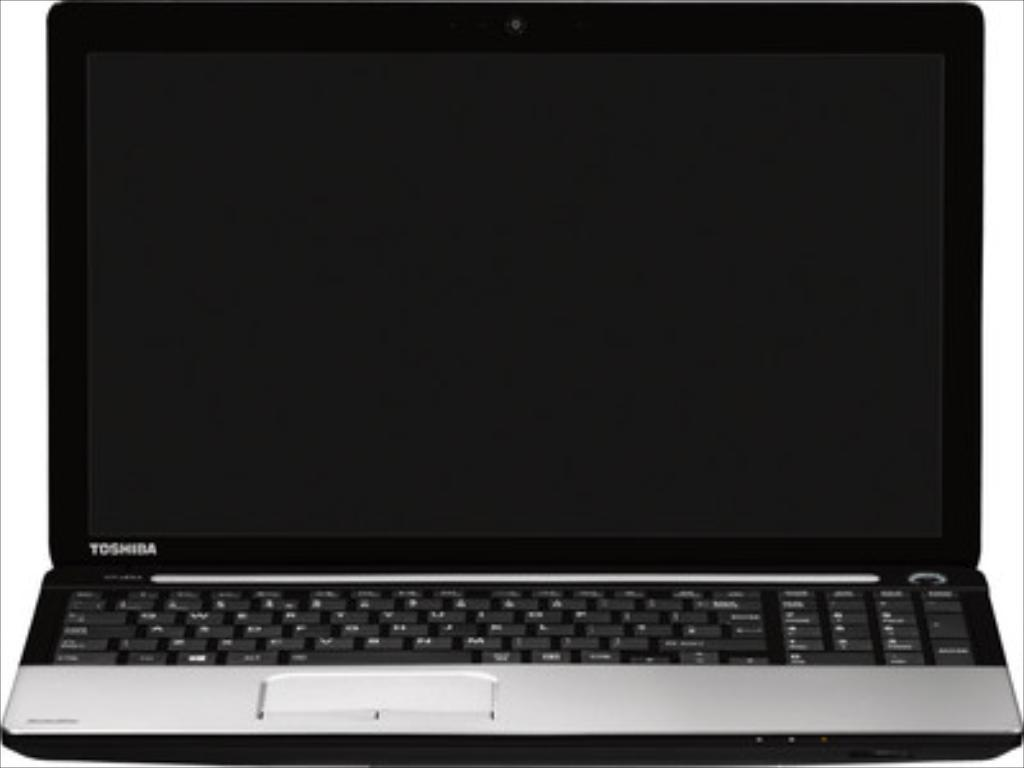<image>
Write a terse but informative summary of the picture. A Toshiba brand laptop sits with its cover open. 